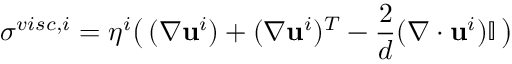<formula> <loc_0><loc_0><loc_500><loc_500>\sigma ^ { v i s c , i } = \eta ^ { i } \left ( \, ( \nabla \mathbf u ^ { i } ) + ( \nabla \mathbf u ^ { i } ) ^ { T } - \frac { 2 } { d } ( \nabla \cdot \mathbf u ^ { i } ) \mathbb { I } \, \right )</formula> 